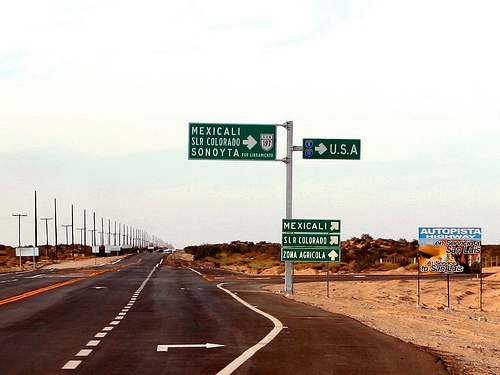Describe the objects in this image and their specific colors. I can see various objects in this image with different colors. 